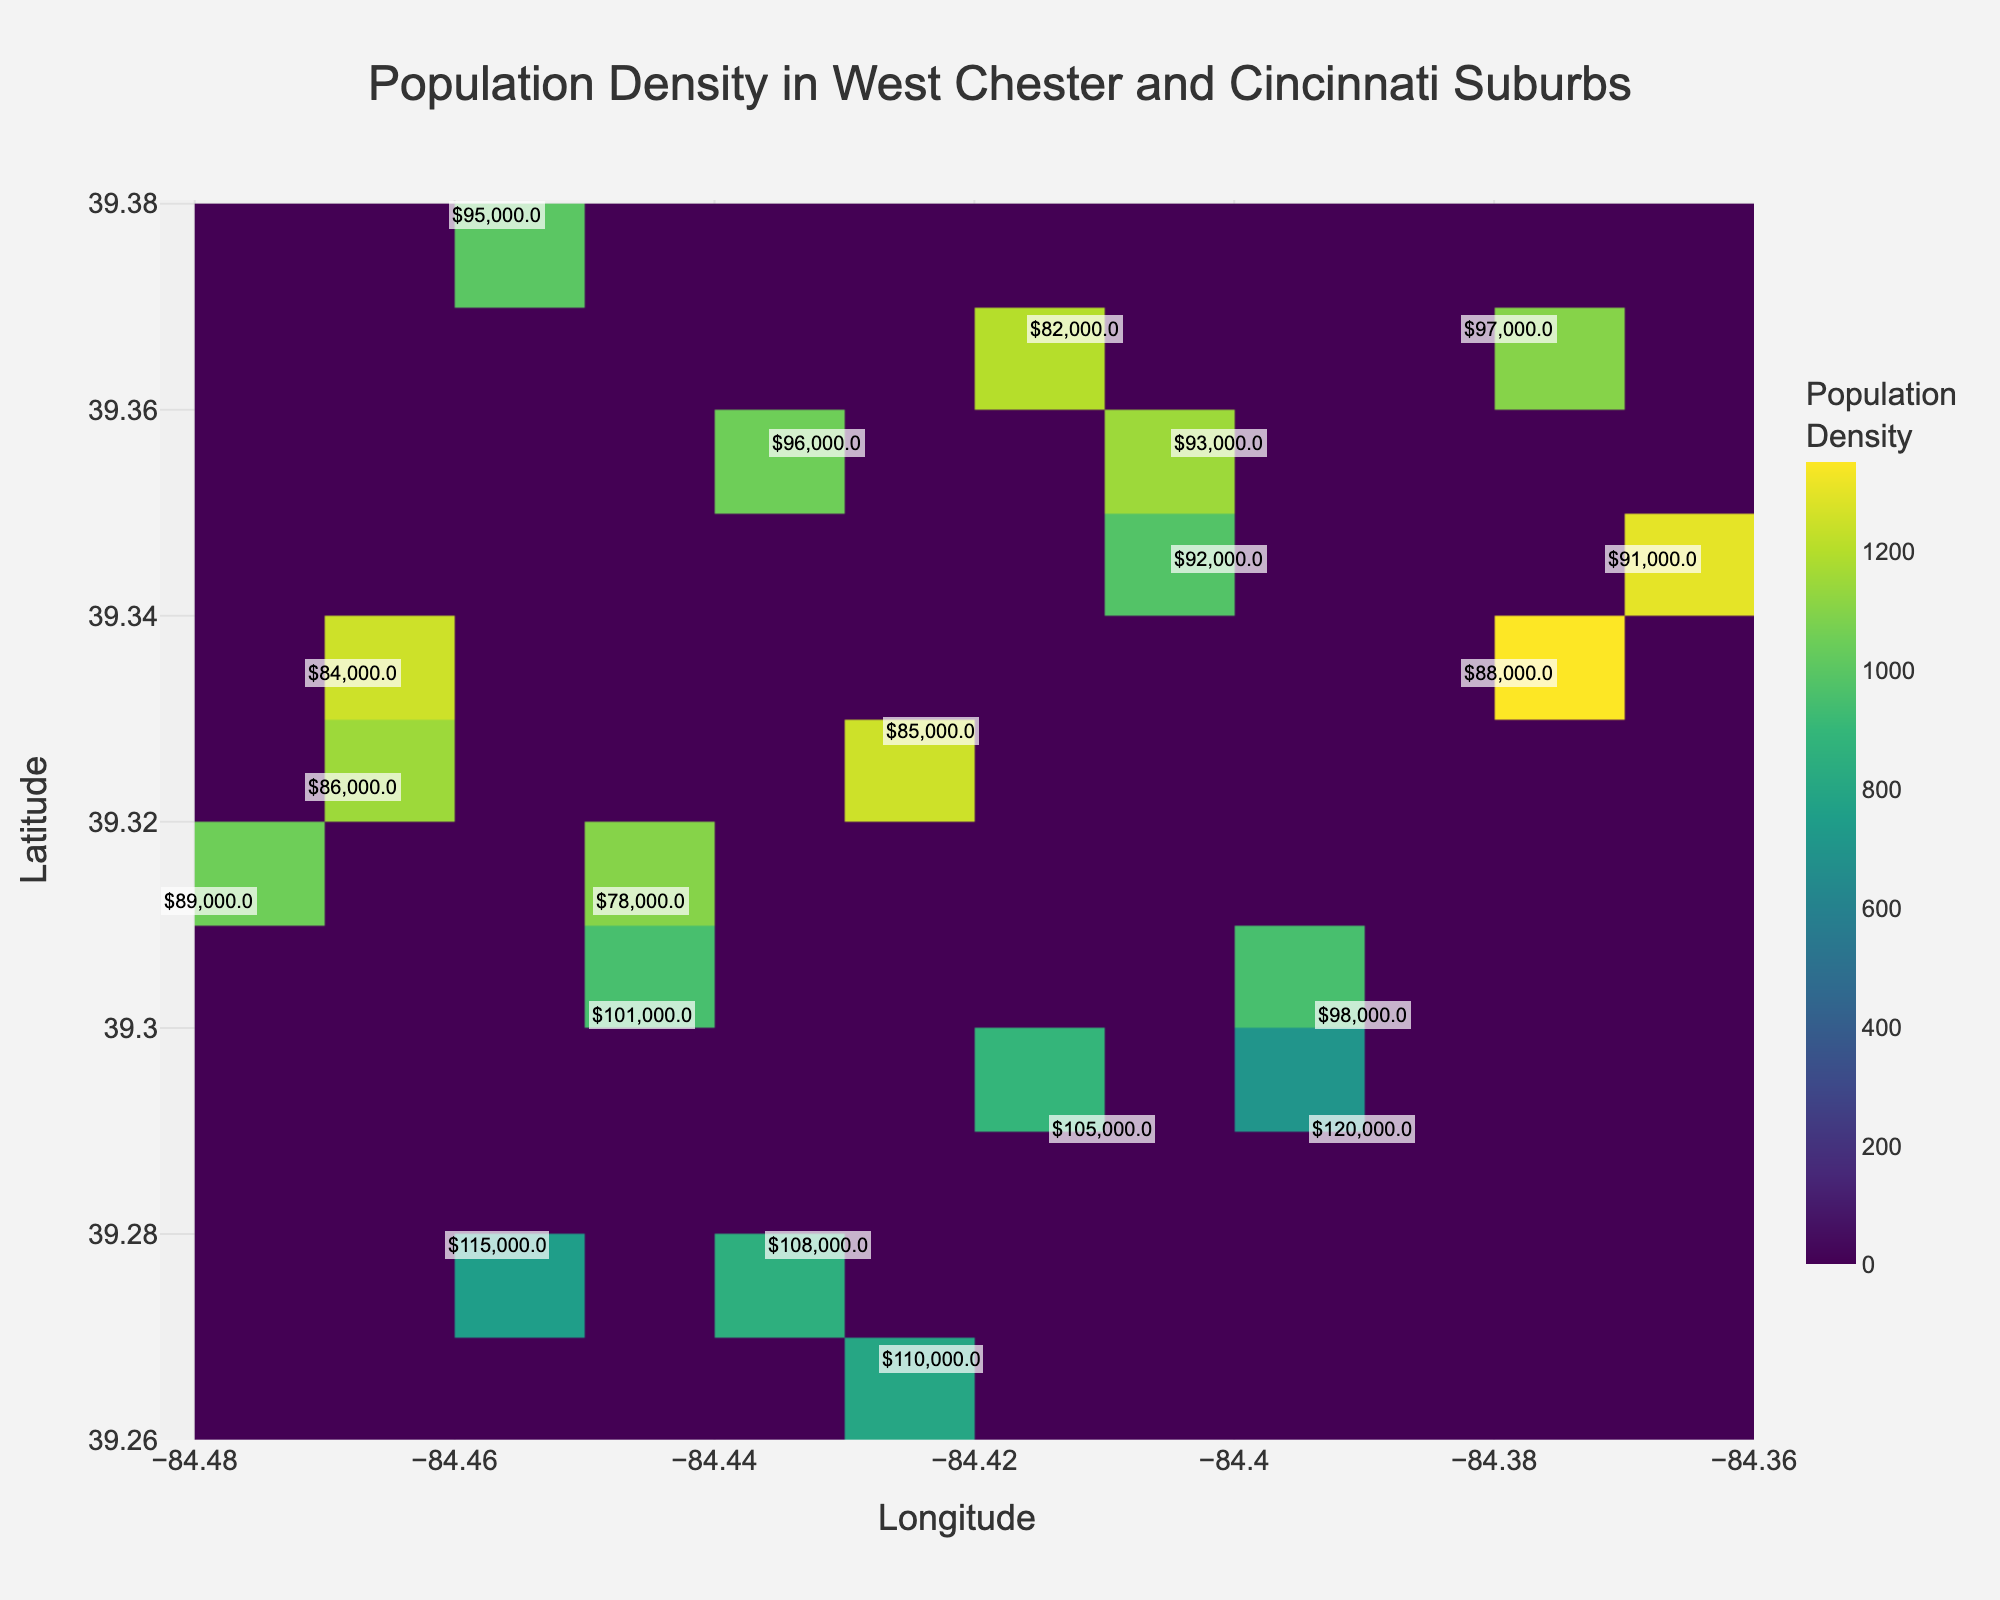what's the title of the figure? The title of the figure is shown at the top center of the plot. It helps in identifying what the plot is about. In this case, the title reads "Population Density in West Chester and Cincinnati Suburbs".
Answer: Population Density in West Chester and Cincinnati Suburbs what are the axes labels in the plot? The axes labels are located along the x and y axes of the plot. The x-axis is labeled "Longitude" and the y-axis is labeled "Latitude". This indicates that the plot shows geographical locations.
Answer: Longitude and Latitude which area has the highest population density according to the plot? By analyzing the color intensity in the hexbin plot, the area with the darkest or most intense color has the highest population density. Locate the bin with the darkest shade within the plot for the answer.
Answer: Around coordinates (39.3345, -84.3789) what household income corresponds to the highest population density area? The figure includes text annotations that display household incomes at specific coordinates. Check the coordinates around the highest population density area for the household income annotation.
Answer: $88,000 compare the population density between the coordinates (39.3123, -84.4789) and (39.3012, -84.4456). Which has a higher density? Compare the color intensity at the coordinates (39.3123, -84.4789) and (39.3012, -84.4456). The coordinates with a darker color indicate a higher population density.
Answer: (39.3123, -84.4789) what is the average household income for areas with a population density over 1000? Identify the annotations in regions where population density is visually indicated to be over 1000. Extract the household incomes of these regions and then compute their average. For the data points: $85,000, $78,000, $88,000, etc. Sum these values and divide by the number of these data points.
Answer: $91,250 what is the lowest population density displayed in the plot and which coordinates does it correspond to? Find the bin with the lightest color intensity, indicating the lowest population density. Look at the coordinates of this bin and refer to the associated population density text.
Answer: 700 at (39.2901, -84.3901) how does population density in coordinate (39.2678, -84.4234) compare to coordinate (39.3789, -84.4567)? Compare the color intensity in the plot at the coordinates (39.2678, -84.4234) and (39.3789, -84.4567). The coordinate with higher intensity has higher population density.
Answer: (39.2678, -84.4234) has higher density what's the range of household incomes in the plot? Identify the lowest and highest household income values annotated in the plot. The range can be calculated by subtracting the lowest value from the highest value.
Answer: $120,000 - $78,000 = $42,000 in the area with coordinates (39.3234, -84.4678), is the population density higher or lower than 1000? Check the color intensity at the coordinates (39.3234, -84.4678). Compare it with the intensity levels indicating population density over 1000.
Answer: Higher 